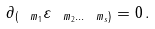<formula> <loc_0><loc_0><loc_500><loc_500>\partial _ { ( \ m _ { 1 } } \varepsilon _ { \ m _ { 2 } \dots \ m _ { s } ) } = 0 \, .</formula> 